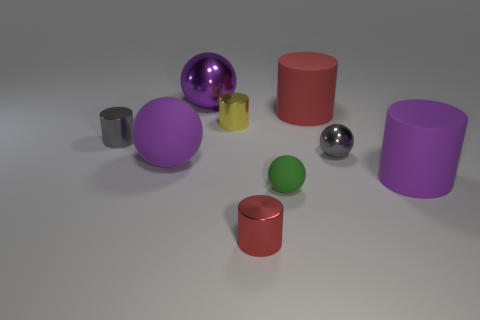Subtract all green rubber balls. How many balls are left? 3 Subtract all spheres. How many objects are left? 5 Add 1 red things. How many objects exist? 10 Subtract 3 balls. How many balls are left? 1 Subtract all brown cylinders. How many purple spheres are left? 2 Subtract all large blue metal things. Subtract all gray shiny balls. How many objects are left? 8 Add 5 large red objects. How many large red objects are left? 6 Add 7 big red spheres. How many big red spheres exist? 7 Subtract all green balls. How many balls are left? 3 Subtract 1 purple cylinders. How many objects are left? 8 